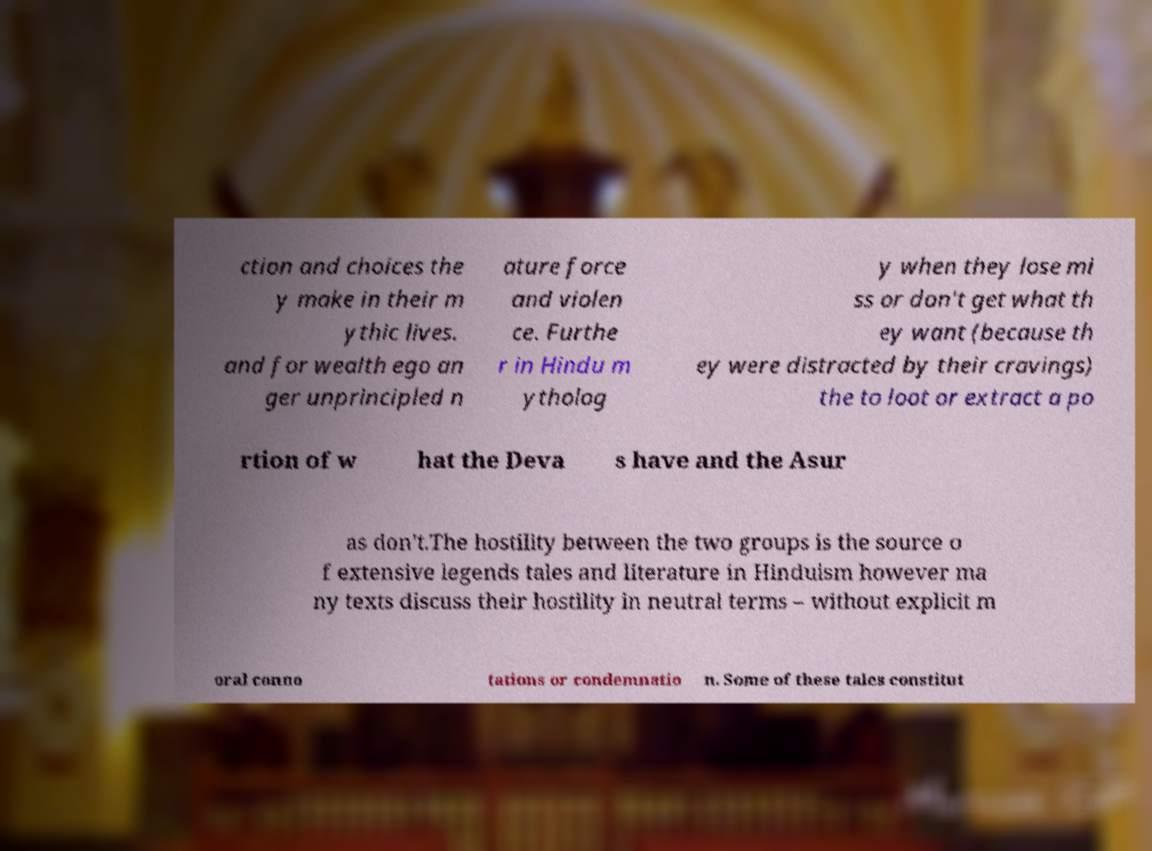Could you assist in decoding the text presented in this image and type it out clearly? ction and choices the y make in their m ythic lives. and for wealth ego an ger unprincipled n ature force and violen ce. Furthe r in Hindu m ytholog y when they lose mi ss or don't get what th ey want (because th ey were distracted by their cravings) the to loot or extract a po rtion of w hat the Deva s have and the Asur as don't.The hostility between the two groups is the source o f extensive legends tales and literature in Hinduism however ma ny texts discuss their hostility in neutral terms – without explicit m oral conno tations or condemnatio n. Some of these tales constitut 